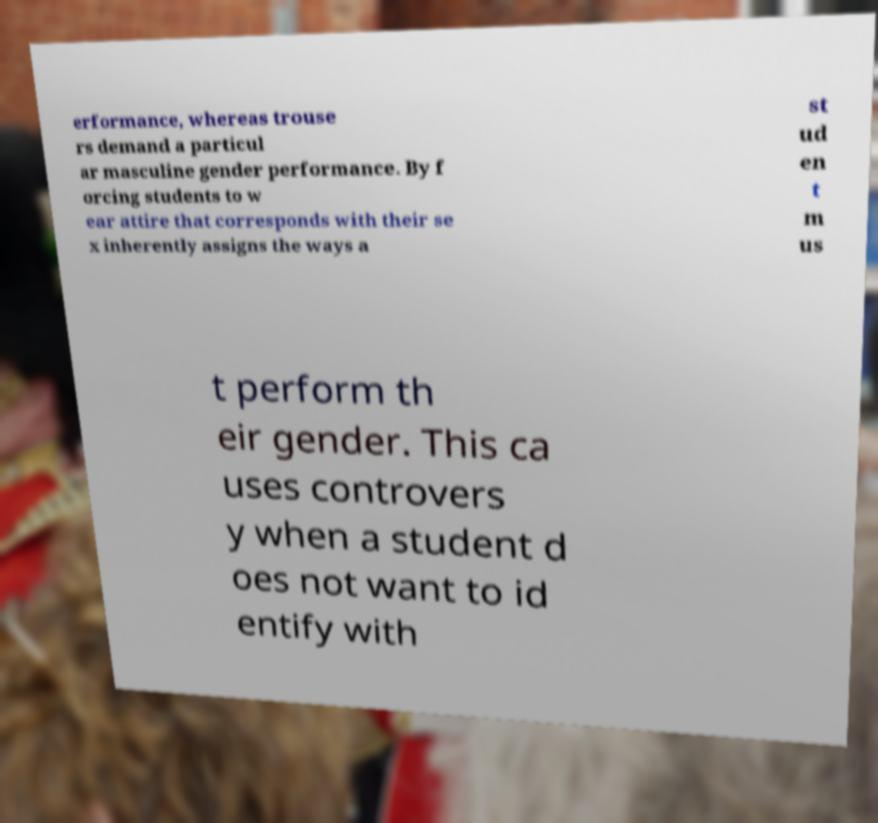What messages or text are displayed in this image? I need them in a readable, typed format. erformance, whereas trouse rs demand a particul ar masculine gender performance. By f orcing students to w ear attire that corresponds with their se x inherently assigns the ways a st ud en t m us t perform th eir gender. This ca uses controvers y when a student d oes not want to id entify with 